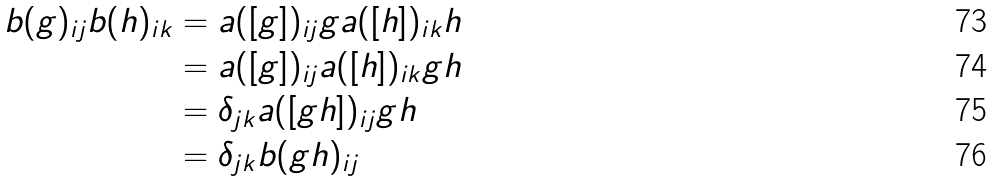<formula> <loc_0><loc_0><loc_500><loc_500>b ( g ) _ { i j } b ( h ) _ { i k } & = a ( [ g ] ) _ { i j } g a ( [ h ] ) _ { i k } h \\ & = a ( [ g ] ) _ { i j } a ( [ h ] ) _ { i k } g h \\ & = \delta _ { j k } a ( [ g h ] ) _ { i j } g h \\ & = \delta _ { j k } b ( g h ) _ { i j }</formula> 